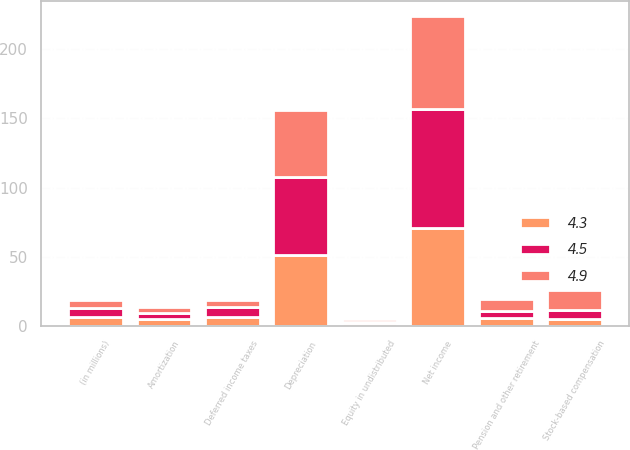Convert chart to OTSL. <chart><loc_0><loc_0><loc_500><loc_500><stacked_bar_chart><ecel><fcel>(in millions)<fcel>Net income<fcel>Depreciation<fcel>Amortization<fcel>Stock-based compensation<fcel>Deferred income taxes<fcel>Pension and other retirement<fcel>Equity in undistributed<nl><fcel>4.5<fcel>6.4<fcel>86<fcel>56.1<fcel>4.5<fcel>6.4<fcel>7.3<fcel>4.9<fcel>0.7<nl><fcel>4.3<fcel>6.4<fcel>70.7<fcel>51.6<fcel>5<fcel>5.1<fcel>6.4<fcel>5.9<fcel>2.4<nl><fcel>4.9<fcel>6.4<fcel>67.1<fcel>48.1<fcel>4.6<fcel>14.5<fcel>4.9<fcel>8.9<fcel>1.9<nl></chart> 